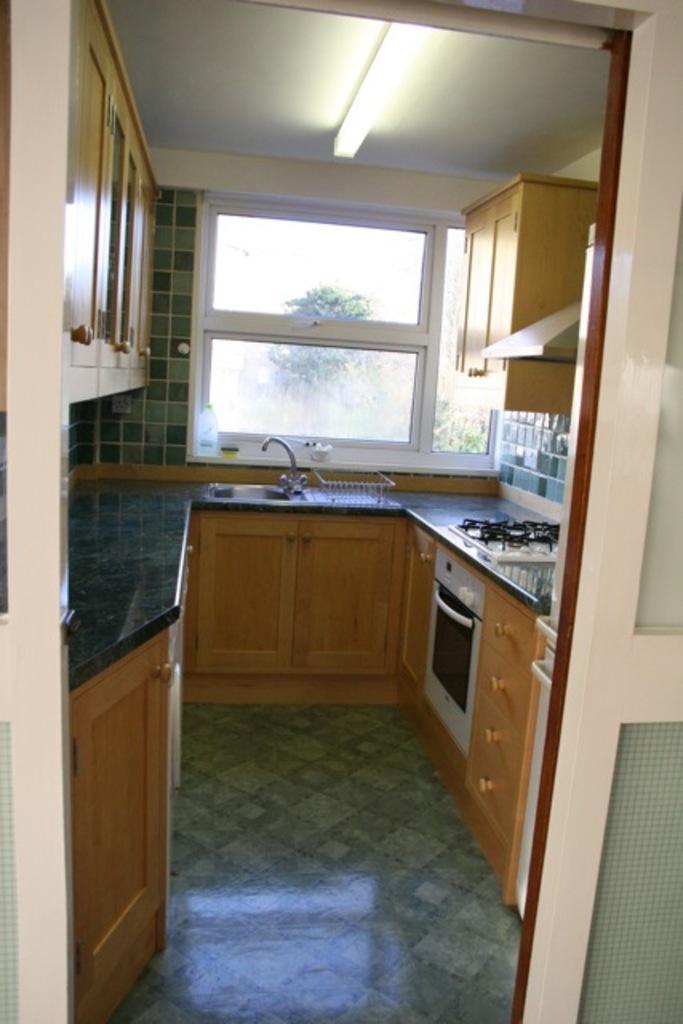Describe this image in one or two sentences. In this image I can see a kitchen cabinet, stove and a wash basin. On the top I can see shelves, window, trees and a rooftop on which a light is mounted. This image is taken in a kitchen room. 